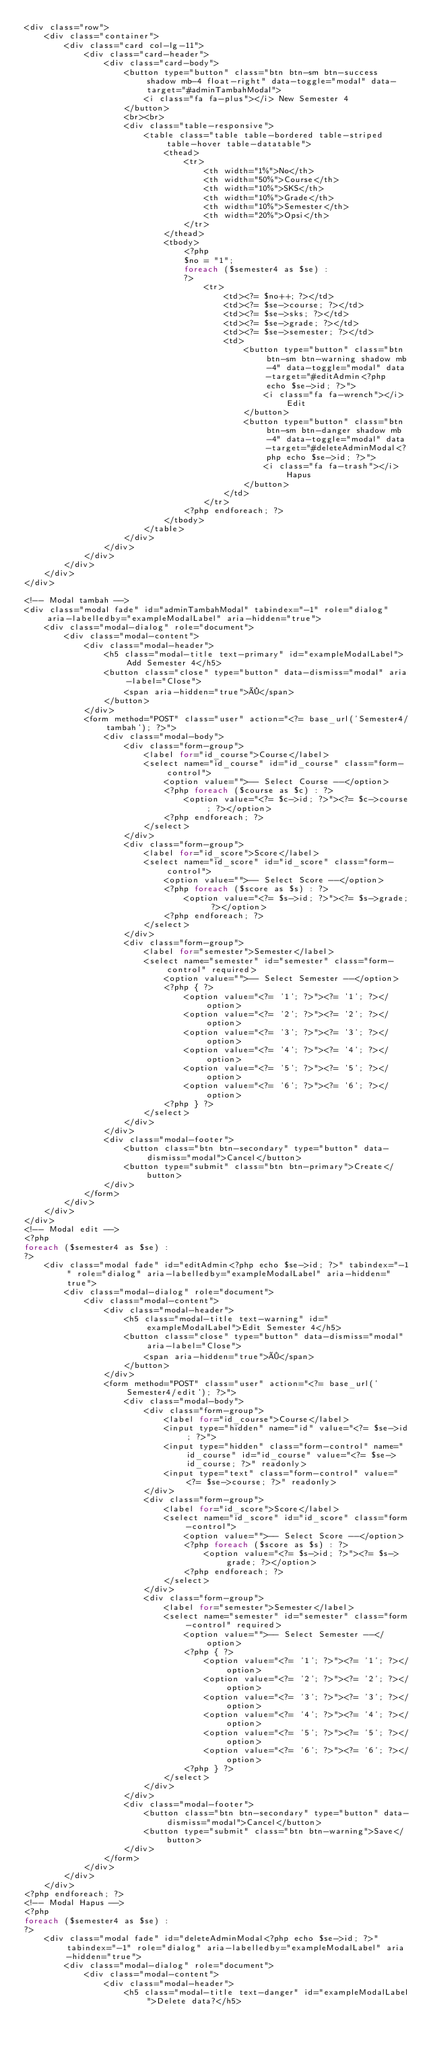<code> <loc_0><loc_0><loc_500><loc_500><_PHP_><div class="row">
    <div class="container">
        <div class="card col-lg-11">
            <div class="card-header">
                <div class="card-body">
                    <button type="button" class="btn btn-sm btn-success shadow mb-4 float-right" data-toggle="modal" data-target="#adminTambahModal">
                        <i class="fa fa-plus"></i> New Semester 4
                    </button>
                    <br><br>
                    <div class="table-responsive">
                        <table class="table table-bordered table-striped table-hover table-datatable">
                            <thead>
                                <tr>
                                    <th width="1%">No</th>
                                    <th width="50%">Course</th>
                                    <th width="10%">SKS</th>
                                    <th width="10%">Grade</th>
                                    <th width="10%">Semester</th>
                                    <th width="20%">Opsi</th>
                                </tr>
                            </thead>
                            <tbody>
                                <?php
                                $no = "1";
                                foreach ($semester4 as $se) :
                                ?>
                                    <tr>
                                        <td><?= $no++; ?></td>
                                        <td><?= $se->course; ?></td>
                                        <td><?= $se->sks; ?></td>
                                        <td><?= $se->grade; ?></td>
                                        <td><?= $se->semester; ?></td>
                                        <td>
                                            <button type="button" class="btn btn-sm btn-warning shadow mb-4" data-toggle="modal" data-target="#editAdmin<?php echo $se->id; ?>">
                                                <i class="fa fa-wrench"></i> Edit
                                            </button>
                                            <button type="button" class="btn btn-sm btn-danger shadow mb-4" data-toggle="modal" data-target="#deleteAdminModal<?php echo $se->id; ?>">
                                                <i class="fa fa-trash"></i> Hapus
                                            </button>
                                        </td>
                                    </tr>
                                <?php endforeach; ?>
                            </tbody>
                        </table>
                    </div>
                </div>
            </div>
        </div>
    </div>
</div>

<!-- Modal tambah -->
<div class="modal fade" id="adminTambahModal" tabindex="-1" role="dialog" aria-labelledby="exampleModalLabel" aria-hidden="true">
    <div class="modal-dialog" role="document">
        <div class="modal-content">
            <div class="modal-header">
                <h5 class="modal-title text-primary" id="exampleModalLabel">Add Semester 4</h5>
                <button class="close" type="button" data-dismiss="modal" aria-label="Close">
                    <span aria-hidden="true">×</span>
                </button>
            </div>
            <form method="POST" class="user" action="<?= base_url('Semester4/tambah'); ?>">
                <div class="modal-body">
                    <div class="form-group">
                        <label for="id_course">Course</label>
                        <select name="id_course" id="id_course" class="form-control">
                            <option value="">-- Select Course --</option>
                            <?php foreach ($course as $c) : ?>
                                <option value="<?= $c->id; ?>"><?= $c->course; ?></option>
                            <?php endforeach; ?>
                        </select>
                    </div>
                    <div class="form-group">
                        <label for="id_score">Score</label>
                        <select name="id_score" id="id_score" class="form-control">
                            <option value="">-- Select Score --</option>
                            <?php foreach ($score as $s) : ?>
                                <option value="<?= $s->id; ?>"><?= $s->grade; ?></option>
                            <?php endforeach; ?>
                        </select>
                    </div>
                    <div class="form-group">
                        <label for="semester">Semester</label>
                        <select name="semester" id="semester" class="form-control" required>
                            <option value="">-- Select Semester --</option>
                            <?php { ?>
                                <option value="<?= '1'; ?>"><?= '1'; ?></option>
                                <option value="<?= '2'; ?>"><?= '2'; ?></option>
                                <option value="<?= '3'; ?>"><?= '3'; ?></option>
                                <option value="<?= '4'; ?>"><?= '4'; ?></option>
                                <option value="<?= '5'; ?>"><?= '5'; ?></option>
                                <option value="<?= '6'; ?>"><?= '6'; ?></option>
                            <?php } ?>
                        </select>
                    </div>
                </div>
                <div class="modal-footer">
                    <button class="btn btn-secondary" type="button" data-dismiss="modal">Cancel</button>
                    <button type="submit" class="btn btn-primary">Create</button>
                </div>
            </form>
        </div>
    </div>
</div>
<!-- Modal edit -->
<?php
foreach ($semester4 as $se) :
?>
    <div class="modal fade" id="editAdmin<?php echo $se->id; ?>" tabindex="-1" role="dialog" aria-labelledby="exampleModalLabel" aria-hidden="true">
        <div class="modal-dialog" role="document">
            <div class="modal-content">
                <div class="modal-header">
                    <h5 class="modal-title text-warning" id="exampleModalLabel">Edit Semester 4</h5>
                    <button class="close" type="button" data-dismiss="modal" aria-label="Close">
                        <span aria-hidden="true">×</span>
                    </button>
                </div>
                <form method="POST" class="user" action="<?= base_url('Semester4/edit'); ?>">
                    <div class="modal-body">
                        <div class="form-group">
                            <label for="id_course">Course</label>
                            <input type="hidden" name="id" value="<?= $se->id; ?>">
                            <input type="hidden" class="form-control" name="id_course" id="id_course" value="<?= $se->id_course; ?>" readonly>
                            <input type="text" class="form-control" value="<?= $se->course; ?>" readonly>
                        </div>
                        <div class="form-group">
                            <label for="id_score">Score</label>
                            <select name="id_score" id="id_score" class="form-control">
                                <option value="">-- Select Score --</option>
                                <?php foreach ($score as $s) : ?>
                                    <option value="<?= $s->id; ?>"><?= $s->grade; ?></option>
                                <?php endforeach; ?>
                            </select>
                        </div>
                        <div class="form-group">
                            <label for="semester">Semester</label>
                            <select name="semester" id="semester" class="form-control" required>
                                <option value="">-- Select Semester --</option>
                                <?php { ?>
                                    <option value="<?= '1'; ?>"><?= '1'; ?></option>
                                    <option value="<?= '2'; ?>"><?= '2'; ?></option>
                                    <option value="<?= '3'; ?>"><?= '3'; ?></option>
                                    <option value="<?= '4'; ?>"><?= '4'; ?></option>
                                    <option value="<?= '5'; ?>"><?= '5'; ?></option>
                                    <option value="<?= '6'; ?>"><?= '6'; ?></option>
                                <?php } ?>
                            </select>
                        </div>
                    </div>
                    <div class="modal-footer">
                        <button class="btn btn-secondary" type="button" data-dismiss="modal">Cancel</button>
                        <button type="submit" class="btn btn-warning">Save</button>
                    </div>
                </form>
            </div>
        </div>
    </div>
<?php endforeach; ?>
<!-- Modal Hapus -->
<?php
foreach ($semester4 as $se) :
?>
    <div class="modal fade" id="deleteAdminModal<?php echo $se->id; ?>" tabindex="-1" role="dialog" aria-labelledby="exampleModalLabel" aria-hidden="true">
        <div class="modal-dialog" role="document">
            <div class="modal-content">
                <div class="modal-header">
                    <h5 class="modal-title text-danger" id="exampleModalLabel">Delete data?</h5></code> 